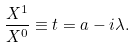Convert formula to latex. <formula><loc_0><loc_0><loc_500><loc_500>\frac { X ^ { 1 } } { X ^ { 0 } } \equiv t = a - i \lambda .</formula> 